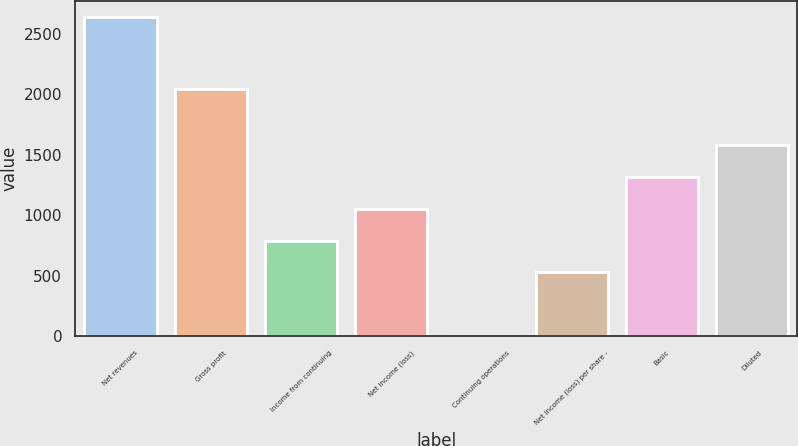Convert chart to OTSL. <chart><loc_0><loc_0><loc_500><loc_500><bar_chart><fcel>Net revenues<fcel>Gross profit<fcel>Income from continuing<fcel>Net income (loss)<fcel>Continuing operations<fcel>Net income (loss) per share -<fcel>Basic<fcel>Diluted<nl><fcel>2640<fcel>2043<fcel>792.46<fcel>1056.4<fcel>0.64<fcel>528.52<fcel>1320.34<fcel>1584.28<nl></chart> 